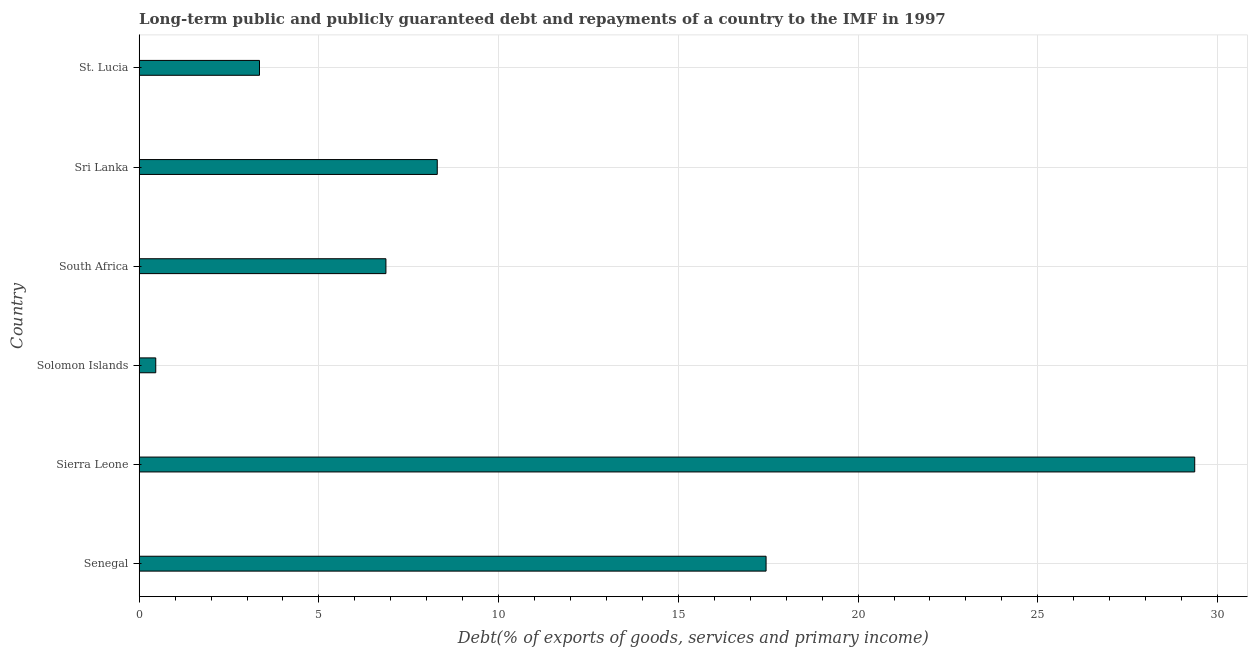What is the title of the graph?
Make the answer very short. Long-term public and publicly guaranteed debt and repayments of a country to the IMF in 1997. What is the label or title of the X-axis?
Keep it short and to the point. Debt(% of exports of goods, services and primary income). What is the debt service in South Africa?
Provide a short and direct response. 6.87. Across all countries, what is the maximum debt service?
Ensure brevity in your answer.  29.37. Across all countries, what is the minimum debt service?
Your answer should be compact. 0.46. In which country was the debt service maximum?
Offer a very short reply. Sierra Leone. In which country was the debt service minimum?
Ensure brevity in your answer.  Solomon Islands. What is the sum of the debt service?
Give a very brief answer. 65.78. What is the difference between the debt service in Solomon Islands and St. Lucia?
Your response must be concise. -2.89. What is the average debt service per country?
Your answer should be compact. 10.96. What is the median debt service?
Give a very brief answer. 7.58. In how many countries, is the debt service greater than 22 %?
Your response must be concise. 1. What is the ratio of the debt service in Solomon Islands to that in South Africa?
Provide a succinct answer. 0.07. What is the difference between the highest and the second highest debt service?
Provide a short and direct response. 11.93. What is the difference between the highest and the lowest debt service?
Ensure brevity in your answer.  28.9. In how many countries, is the debt service greater than the average debt service taken over all countries?
Keep it short and to the point. 2. How many bars are there?
Offer a terse response. 6. Are all the bars in the graph horizontal?
Your answer should be very brief. Yes. How many countries are there in the graph?
Offer a very short reply. 6. What is the difference between two consecutive major ticks on the X-axis?
Make the answer very short. 5. Are the values on the major ticks of X-axis written in scientific E-notation?
Your answer should be very brief. No. What is the Debt(% of exports of goods, services and primary income) in Senegal?
Offer a very short reply. 17.44. What is the Debt(% of exports of goods, services and primary income) in Sierra Leone?
Give a very brief answer. 29.37. What is the Debt(% of exports of goods, services and primary income) in Solomon Islands?
Keep it short and to the point. 0.46. What is the Debt(% of exports of goods, services and primary income) in South Africa?
Ensure brevity in your answer.  6.87. What is the Debt(% of exports of goods, services and primary income) of Sri Lanka?
Ensure brevity in your answer.  8.29. What is the Debt(% of exports of goods, services and primary income) in St. Lucia?
Offer a terse response. 3.35. What is the difference between the Debt(% of exports of goods, services and primary income) in Senegal and Sierra Leone?
Ensure brevity in your answer.  -11.92. What is the difference between the Debt(% of exports of goods, services and primary income) in Senegal and Solomon Islands?
Provide a succinct answer. 16.98. What is the difference between the Debt(% of exports of goods, services and primary income) in Senegal and South Africa?
Your response must be concise. 10.58. What is the difference between the Debt(% of exports of goods, services and primary income) in Senegal and Sri Lanka?
Offer a very short reply. 9.15. What is the difference between the Debt(% of exports of goods, services and primary income) in Senegal and St. Lucia?
Provide a succinct answer. 14.09. What is the difference between the Debt(% of exports of goods, services and primary income) in Sierra Leone and Solomon Islands?
Your response must be concise. 28.9. What is the difference between the Debt(% of exports of goods, services and primary income) in Sierra Leone and South Africa?
Keep it short and to the point. 22.5. What is the difference between the Debt(% of exports of goods, services and primary income) in Sierra Leone and Sri Lanka?
Your answer should be compact. 21.07. What is the difference between the Debt(% of exports of goods, services and primary income) in Sierra Leone and St. Lucia?
Offer a terse response. 26.02. What is the difference between the Debt(% of exports of goods, services and primary income) in Solomon Islands and South Africa?
Ensure brevity in your answer.  -6.4. What is the difference between the Debt(% of exports of goods, services and primary income) in Solomon Islands and Sri Lanka?
Offer a terse response. -7.83. What is the difference between the Debt(% of exports of goods, services and primary income) in Solomon Islands and St. Lucia?
Your answer should be compact. -2.89. What is the difference between the Debt(% of exports of goods, services and primary income) in South Africa and Sri Lanka?
Your response must be concise. -1.43. What is the difference between the Debt(% of exports of goods, services and primary income) in South Africa and St. Lucia?
Offer a terse response. 3.52. What is the difference between the Debt(% of exports of goods, services and primary income) in Sri Lanka and St. Lucia?
Provide a short and direct response. 4.95. What is the ratio of the Debt(% of exports of goods, services and primary income) in Senegal to that in Sierra Leone?
Provide a succinct answer. 0.59. What is the ratio of the Debt(% of exports of goods, services and primary income) in Senegal to that in Solomon Islands?
Ensure brevity in your answer.  37.8. What is the ratio of the Debt(% of exports of goods, services and primary income) in Senegal to that in South Africa?
Give a very brief answer. 2.54. What is the ratio of the Debt(% of exports of goods, services and primary income) in Senegal to that in Sri Lanka?
Offer a terse response. 2.1. What is the ratio of the Debt(% of exports of goods, services and primary income) in Senegal to that in St. Lucia?
Your answer should be very brief. 5.21. What is the ratio of the Debt(% of exports of goods, services and primary income) in Sierra Leone to that in Solomon Islands?
Keep it short and to the point. 63.64. What is the ratio of the Debt(% of exports of goods, services and primary income) in Sierra Leone to that in South Africa?
Provide a short and direct response. 4.28. What is the ratio of the Debt(% of exports of goods, services and primary income) in Sierra Leone to that in Sri Lanka?
Your answer should be compact. 3.54. What is the ratio of the Debt(% of exports of goods, services and primary income) in Sierra Leone to that in St. Lucia?
Provide a short and direct response. 8.77. What is the ratio of the Debt(% of exports of goods, services and primary income) in Solomon Islands to that in South Africa?
Your answer should be compact. 0.07. What is the ratio of the Debt(% of exports of goods, services and primary income) in Solomon Islands to that in Sri Lanka?
Your response must be concise. 0.06. What is the ratio of the Debt(% of exports of goods, services and primary income) in Solomon Islands to that in St. Lucia?
Give a very brief answer. 0.14. What is the ratio of the Debt(% of exports of goods, services and primary income) in South Africa to that in Sri Lanka?
Provide a short and direct response. 0.83. What is the ratio of the Debt(% of exports of goods, services and primary income) in South Africa to that in St. Lucia?
Your answer should be very brief. 2.05. What is the ratio of the Debt(% of exports of goods, services and primary income) in Sri Lanka to that in St. Lucia?
Your answer should be very brief. 2.48. 